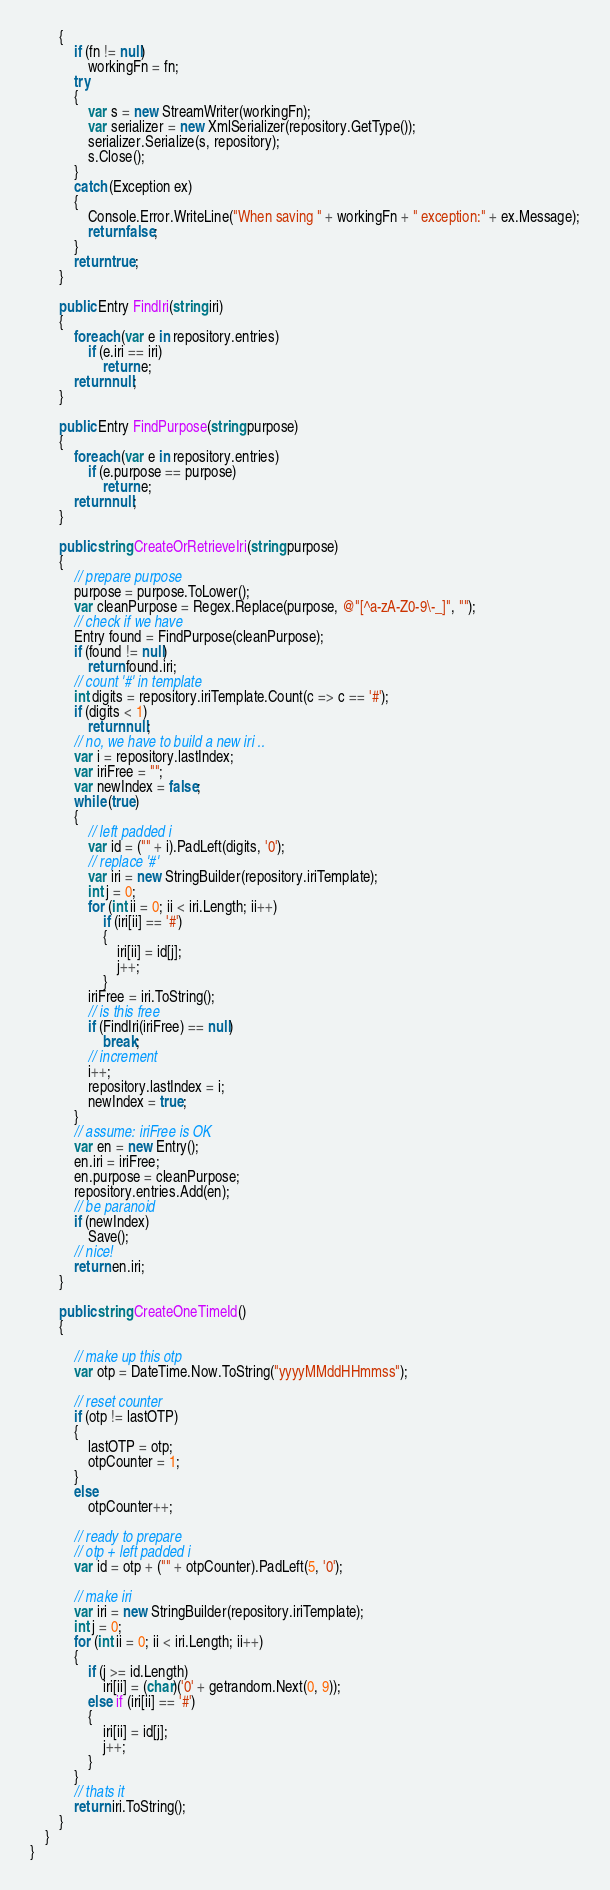<code> <loc_0><loc_0><loc_500><loc_500><_C#_>        {
            if (fn != null)
                workingFn = fn;
            try
            {
                var s = new StreamWriter(workingFn);
                var serializer = new XmlSerializer(repository.GetType());
                serializer.Serialize(s, repository);
                s.Close();
            }
            catch (Exception ex)
            {
                Console.Error.WriteLine("When saving " + workingFn + " exception:" + ex.Message);
                return false;
            }
            return true;
        }

        public Entry FindIri(string iri)
        {
            foreach (var e in repository.entries)
                if (e.iri == iri)
                    return e;
            return null;
        }

        public Entry FindPurpose(string purpose)
        {
            foreach (var e in repository.entries)
                if (e.purpose == purpose)
                    return e;
            return null;
        }

        public string CreateOrRetrieveIri(string purpose)
        {
            // prepare purpose
            purpose = purpose.ToLower();
            var cleanPurpose = Regex.Replace(purpose, @"[^a-zA-Z0-9\-_]", "");
            // check if we have
            Entry found = FindPurpose(cleanPurpose);
            if (found != null)
                return found.iri;
            // count '#' in template
            int digits = repository.iriTemplate.Count(c => c == '#');
            if (digits < 1)
                return null;
            // no, we have to build a new iri ..
            var i = repository.lastIndex;
            var iriFree = "";
            var newIndex = false;
            while (true)
            {
                // left padded i
                var id = ("" + i).PadLeft(digits, '0');
                // replace '#'
                var iri = new StringBuilder(repository.iriTemplate);
                int j = 0;
                for (int ii = 0; ii < iri.Length; ii++)
                    if (iri[ii] == '#')
                    {
                        iri[ii] = id[j];
                        j++;
                    }
                iriFree = iri.ToString();
                // is this free
                if (FindIri(iriFree) == null)
                    break;
                // increment
                i++;
                repository.lastIndex = i;
                newIndex = true;
            }
            // assume: iriFree is OK
            var en = new Entry();
            en.iri = iriFree;
            en.purpose = cleanPurpose;
            repository.entries.Add(en);
            // be paranoid
            if (newIndex)
                Save();
            // nice!
            return en.iri;
        }

        public string CreateOneTimeId()
        {

            // make up this otp
            var otp = DateTime.Now.ToString("yyyyMMddHHmmss");

            // reset counter
            if (otp != lastOTP)
            {
                lastOTP = otp;
                otpCounter = 1;
            }
            else
                otpCounter++;

            // ready to prepare
            // otp + left padded i
            var id = otp + ("" + otpCounter).PadLeft(5, '0');

            // make iri
            var iri = new StringBuilder(repository.iriTemplate);
            int j = 0;
            for (int ii = 0; ii < iri.Length; ii++)
            {
                if (j >= id.Length)
                    iri[ii] = (char)('0' + getrandom.Next(0, 9));
                else if (iri[ii] == '#')
                {
                    iri[ii] = id[j];
                    j++;
                }
            }
            // thats it
            return iri.ToString();
        }
    }
}
</code> 